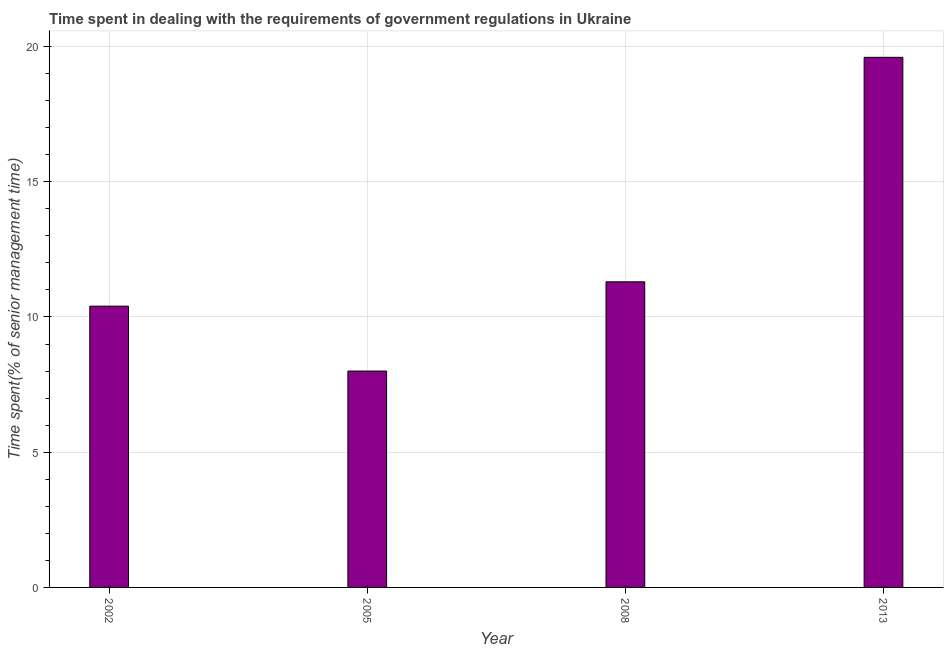Does the graph contain any zero values?
Ensure brevity in your answer.  No. Does the graph contain grids?
Give a very brief answer. Yes. What is the title of the graph?
Offer a terse response. Time spent in dealing with the requirements of government regulations in Ukraine. What is the label or title of the X-axis?
Provide a succinct answer. Year. What is the label or title of the Y-axis?
Make the answer very short. Time spent(% of senior management time). What is the time spent in dealing with government regulations in 2013?
Offer a terse response. 19.6. Across all years, what is the maximum time spent in dealing with government regulations?
Keep it short and to the point. 19.6. In which year was the time spent in dealing with government regulations minimum?
Your response must be concise. 2005. What is the sum of the time spent in dealing with government regulations?
Make the answer very short. 49.3. What is the difference between the time spent in dealing with government regulations in 2008 and 2013?
Give a very brief answer. -8.3. What is the average time spent in dealing with government regulations per year?
Offer a terse response. 12.32. What is the median time spent in dealing with government regulations?
Provide a succinct answer. 10.85. Do a majority of the years between 2002 and 2013 (inclusive) have time spent in dealing with government regulations greater than 4 %?
Ensure brevity in your answer.  Yes. What is the ratio of the time spent in dealing with government regulations in 2005 to that in 2008?
Your answer should be compact. 0.71. Is the sum of the time spent in dealing with government regulations in 2005 and 2008 greater than the maximum time spent in dealing with government regulations across all years?
Offer a terse response. No. What is the difference between the highest and the lowest time spent in dealing with government regulations?
Your answer should be compact. 11.6. How many bars are there?
Offer a terse response. 4. How many years are there in the graph?
Provide a short and direct response. 4. What is the difference between two consecutive major ticks on the Y-axis?
Make the answer very short. 5. Are the values on the major ticks of Y-axis written in scientific E-notation?
Offer a terse response. No. What is the Time spent(% of senior management time) in 2002?
Provide a short and direct response. 10.4. What is the Time spent(% of senior management time) of 2008?
Provide a succinct answer. 11.3. What is the Time spent(% of senior management time) in 2013?
Provide a succinct answer. 19.6. What is the difference between the Time spent(% of senior management time) in 2002 and 2005?
Your answer should be very brief. 2.4. What is the difference between the Time spent(% of senior management time) in 2002 and 2008?
Ensure brevity in your answer.  -0.9. What is the ratio of the Time spent(% of senior management time) in 2002 to that in 2005?
Provide a succinct answer. 1.3. What is the ratio of the Time spent(% of senior management time) in 2002 to that in 2013?
Provide a short and direct response. 0.53. What is the ratio of the Time spent(% of senior management time) in 2005 to that in 2008?
Your response must be concise. 0.71. What is the ratio of the Time spent(% of senior management time) in 2005 to that in 2013?
Provide a succinct answer. 0.41. What is the ratio of the Time spent(% of senior management time) in 2008 to that in 2013?
Your answer should be very brief. 0.58. 